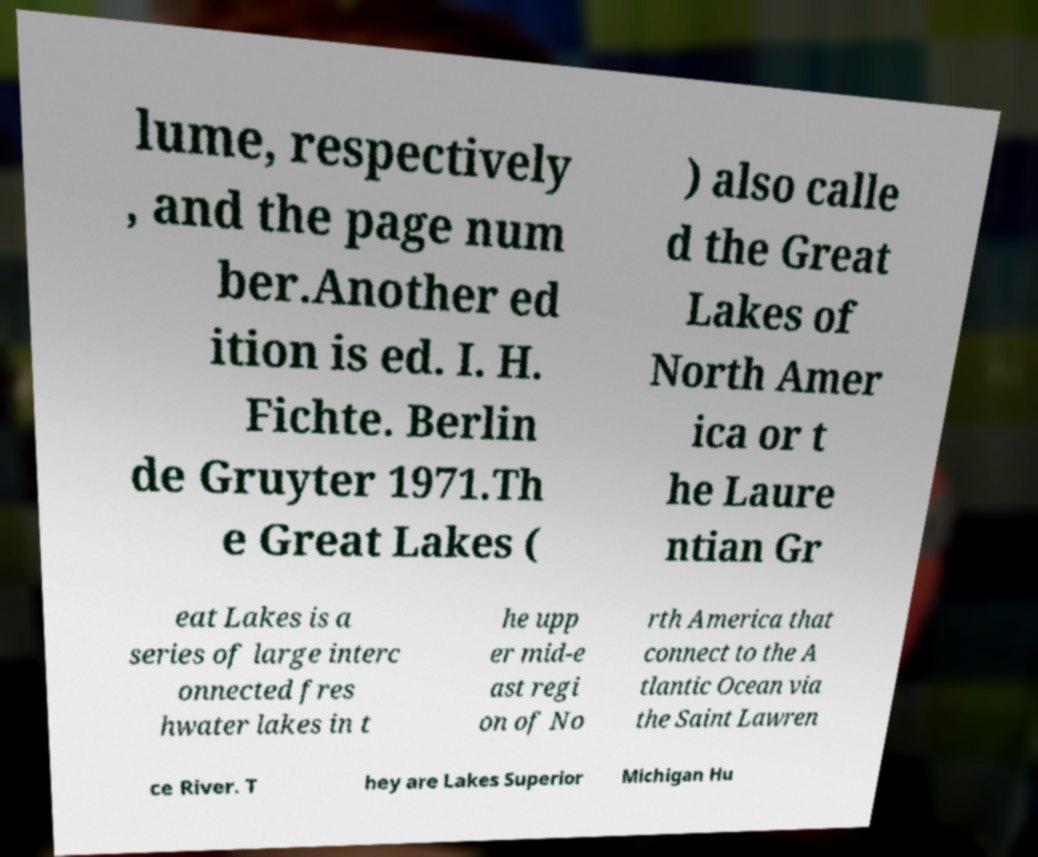Can you accurately transcribe the text from the provided image for me? lume, respectively , and the page num ber.Another ed ition is ed. I. H. Fichte. Berlin de Gruyter 1971.Th e Great Lakes ( ) also calle d the Great Lakes of North Amer ica or t he Laure ntian Gr eat Lakes is a series of large interc onnected fres hwater lakes in t he upp er mid-e ast regi on of No rth America that connect to the A tlantic Ocean via the Saint Lawren ce River. T hey are Lakes Superior Michigan Hu 